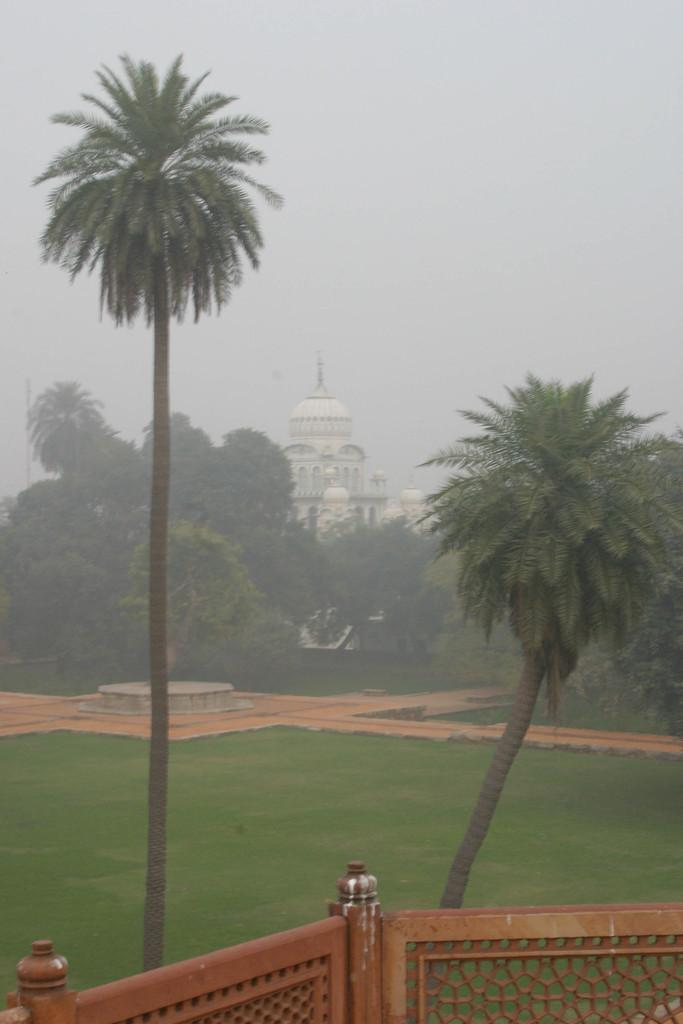What type of structure is visible in the image? There is a building in the image. What type of vegetation is present in the image? There are trees in the image. What can be seen in the foreground of the image? There is a railing in the foreground of the image. What is visible at the top of the image? The sky is visible at the top of the image. What type of ground surface is present in the image? There is grass and pavement in the image. Can you hear the whistle of the appliance in the image? There is no appliance or whistle present in the image. What type of dinner is being served in the image? There is no dinner or food visible in the image. 